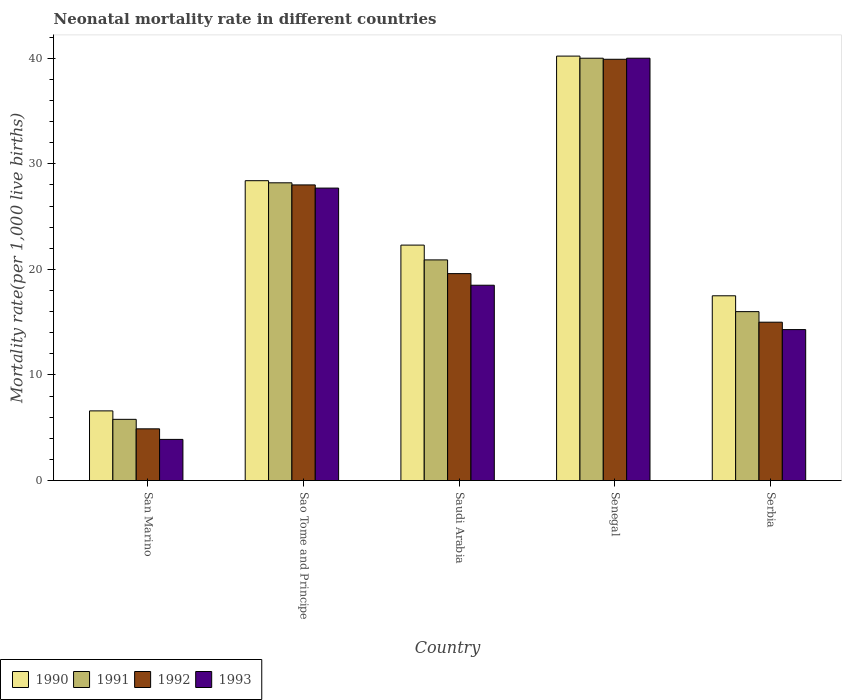How many bars are there on the 1st tick from the left?
Keep it short and to the point. 4. How many bars are there on the 4th tick from the right?
Offer a terse response. 4. What is the label of the 1st group of bars from the left?
Your answer should be compact. San Marino. In how many cases, is the number of bars for a given country not equal to the number of legend labels?
Provide a succinct answer. 0. What is the neonatal mortality rate in 1991 in Sao Tome and Principe?
Provide a succinct answer. 28.2. Across all countries, what is the maximum neonatal mortality rate in 1992?
Your answer should be compact. 39.9. Across all countries, what is the minimum neonatal mortality rate in 1991?
Offer a very short reply. 5.8. In which country was the neonatal mortality rate in 1992 maximum?
Provide a short and direct response. Senegal. In which country was the neonatal mortality rate in 1990 minimum?
Provide a succinct answer. San Marino. What is the total neonatal mortality rate in 1992 in the graph?
Your response must be concise. 107.4. What is the difference between the neonatal mortality rate in 1990 in Senegal and that in Serbia?
Offer a very short reply. 22.7. What is the difference between the neonatal mortality rate in 1992 in San Marino and the neonatal mortality rate in 1990 in Senegal?
Your answer should be compact. -35.3. What is the difference between the neonatal mortality rate of/in 1990 and neonatal mortality rate of/in 1993 in San Marino?
Offer a very short reply. 2.7. Is the neonatal mortality rate in 1992 in Sao Tome and Principe less than that in Saudi Arabia?
Your answer should be very brief. No. What is the difference between the highest and the lowest neonatal mortality rate in 1991?
Offer a terse response. 34.2. Is the sum of the neonatal mortality rate in 1992 in Saudi Arabia and Serbia greater than the maximum neonatal mortality rate in 1991 across all countries?
Keep it short and to the point. No. Is it the case that in every country, the sum of the neonatal mortality rate in 1991 and neonatal mortality rate in 1992 is greater than the neonatal mortality rate in 1990?
Keep it short and to the point. Yes. Are all the bars in the graph horizontal?
Keep it short and to the point. No. How many countries are there in the graph?
Your answer should be compact. 5. What is the difference between two consecutive major ticks on the Y-axis?
Your answer should be very brief. 10. Does the graph contain any zero values?
Keep it short and to the point. No. Where does the legend appear in the graph?
Give a very brief answer. Bottom left. How many legend labels are there?
Provide a short and direct response. 4. What is the title of the graph?
Your answer should be very brief. Neonatal mortality rate in different countries. What is the label or title of the Y-axis?
Your answer should be compact. Mortality rate(per 1,0 live births). What is the Mortality rate(per 1,000 live births) of 1992 in San Marino?
Offer a very short reply. 4.9. What is the Mortality rate(per 1,000 live births) of 1993 in San Marino?
Make the answer very short. 3.9. What is the Mortality rate(per 1,000 live births) of 1990 in Sao Tome and Principe?
Offer a very short reply. 28.4. What is the Mortality rate(per 1,000 live births) of 1991 in Sao Tome and Principe?
Your answer should be very brief. 28.2. What is the Mortality rate(per 1,000 live births) in 1992 in Sao Tome and Principe?
Your answer should be compact. 28. What is the Mortality rate(per 1,000 live births) in 1993 in Sao Tome and Principe?
Give a very brief answer. 27.7. What is the Mortality rate(per 1,000 live births) in 1990 in Saudi Arabia?
Provide a short and direct response. 22.3. What is the Mortality rate(per 1,000 live births) in 1991 in Saudi Arabia?
Your answer should be very brief. 20.9. What is the Mortality rate(per 1,000 live births) in 1992 in Saudi Arabia?
Provide a short and direct response. 19.6. What is the Mortality rate(per 1,000 live births) of 1993 in Saudi Arabia?
Provide a succinct answer. 18.5. What is the Mortality rate(per 1,000 live births) in 1990 in Senegal?
Provide a short and direct response. 40.2. What is the Mortality rate(per 1,000 live births) of 1992 in Senegal?
Offer a terse response. 39.9. What is the Mortality rate(per 1,000 live births) in 1993 in Senegal?
Keep it short and to the point. 40. What is the Mortality rate(per 1,000 live births) in 1991 in Serbia?
Keep it short and to the point. 16. What is the Mortality rate(per 1,000 live births) of 1993 in Serbia?
Provide a succinct answer. 14.3. Across all countries, what is the maximum Mortality rate(per 1,000 live births) in 1990?
Offer a terse response. 40.2. Across all countries, what is the maximum Mortality rate(per 1,000 live births) of 1991?
Give a very brief answer. 40. Across all countries, what is the maximum Mortality rate(per 1,000 live births) in 1992?
Make the answer very short. 39.9. Across all countries, what is the maximum Mortality rate(per 1,000 live births) of 1993?
Your answer should be compact. 40. Across all countries, what is the minimum Mortality rate(per 1,000 live births) of 1990?
Your answer should be compact. 6.6. What is the total Mortality rate(per 1,000 live births) of 1990 in the graph?
Provide a short and direct response. 115. What is the total Mortality rate(per 1,000 live births) of 1991 in the graph?
Offer a terse response. 110.9. What is the total Mortality rate(per 1,000 live births) of 1992 in the graph?
Provide a succinct answer. 107.4. What is the total Mortality rate(per 1,000 live births) of 1993 in the graph?
Keep it short and to the point. 104.4. What is the difference between the Mortality rate(per 1,000 live births) of 1990 in San Marino and that in Sao Tome and Principe?
Ensure brevity in your answer.  -21.8. What is the difference between the Mortality rate(per 1,000 live births) of 1991 in San Marino and that in Sao Tome and Principe?
Keep it short and to the point. -22.4. What is the difference between the Mortality rate(per 1,000 live births) in 1992 in San Marino and that in Sao Tome and Principe?
Keep it short and to the point. -23.1. What is the difference between the Mortality rate(per 1,000 live births) of 1993 in San Marino and that in Sao Tome and Principe?
Your answer should be compact. -23.8. What is the difference between the Mortality rate(per 1,000 live births) in 1990 in San Marino and that in Saudi Arabia?
Provide a short and direct response. -15.7. What is the difference between the Mortality rate(per 1,000 live births) in 1991 in San Marino and that in Saudi Arabia?
Provide a succinct answer. -15.1. What is the difference between the Mortality rate(per 1,000 live births) in 1992 in San Marino and that in Saudi Arabia?
Give a very brief answer. -14.7. What is the difference between the Mortality rate(per 1,000 live births) in 1993 in San Marino and that in Saudi Arabia?
Give a very brief answer. -14.6. What is the difference between the Mortality rate(per 1,000 live births) in 1990 in San Marino and that in Senegal?
Keep it short and to the point. -33.6. What is the difference between the Mortality rate(per 1,000 live births) of 1991 in San Marino and that in Senegal?
Your answer should be compact. -34.2. What is the difference between the Mortality rate(per 1,000 live births) of 1992 in San Marino and that in Senegal?
Keep it short and to the point. -35. What is the difference between the Mortality rate(per 1,000 live births) of 1993 in San Marino and that in Senegal?
Provide a succinct answer. -36.1. What is the difference between the Mortality rate(per 1,000 live births) of 1993 in San Marino and that in Serbia?
Provide a succinct answer. -10.4. What is the difference between the Mortality rate(per 1,000 live births) in 1990 in Sao Tome and Principe and that in Saudi Arabia?
Your response must be concise. 6.1. What is the difference between the Mortality rate(per 1,000 live births) of 1990 in Sao Tome and Principe and that in Senegal?
Ensure brevity in your answer.  -11.8. What is the difference between the Mortality rate(per 1,000 live births) of 1992 in Sao Tome and Principe and that in Senegal?
Ensure brevity in your answer.  -11.9. What is the difference between the Mortality rate(per 1,000 live births) in 1993 in Sao Tome and Principe and that in Senegal?
Provide a short and direct response. -12.3. What is the difference between the Mortality rate(per 1,000 live births) in 1990 in Sao Tome and Principe and that in Serbia?
Your answer should be compact. 10.9. What is the difference between the Mortality rate(per 1,000 live births) in 1992 in Sao Tome and Principe and that in Serbia?
Offer a very short reply. 13. What is the difference between the Mortality rate(per 1,000 live births) of 1993 in Sao Tome and Principe and that in Serbia?
Offer a terse response. 13.4. What is the difference between the Mortality rate(per 1,000 live births) in 1990 in Saudi Arabia and that in Senegal?
Your answer should be very brief. -17.9. What is the difference between the Mortality rate(per 1,000 live births) in 1991 in Saudi Arabia and that in Senegal?
Offer a terse response. -19.1. What is the difference between the Mortality rate(per 1,000 live births) in 1992 in Saudi Arabia and that in Senegal?
Your answer should be very brief. -20.3. What is the difference between the Mortality rate(per 1,000 live births) in 1993 in Saudi Arabia and that in Senegal?
Keep it short and to the point. -21.5. What is the difference between the Mortality rate(per 1,000 live births) of 1992 in Saudi Arabia and that in Serbia?
Provide a short and direct response. 4.6. What is the difference between the Mortality rate(per 1,000 live births) of 1993 in Saudi Arabia and that in Serbia?
Offer a very short reply. 4.2. What is the difference between the Mortality rate(per 1,000 live births) in 1990 in Senegal and that in Serbia?
Provide a short and direct response. 22.7. What is the difference between the Mortality rate(per 1,000 live births) of 1992 in Senegal and that in Serbia?
Make the answer very short. 24.9. What is the difference between the Mortality rate(per 1,000 live births) of 1993 in Senegal and that in Serbia?
Give a very brief answer. 25.7. What is the difference between the Mortality rate(per 1,000 live births) of 1990 in San Marino and the Mortality rate(per 1,000 live births) of 1991 in Sao Tome and Principe?
Ensure brevity in your answer.  -21.6. What is the difference between the Mortality rate(per 1,000 live births) in 1990 in San Marino and the Mortality rate(per 1,000 live births) in 1992 in Sao Tome and Principe?
Keep it short and to the point. -21.4. What is the difference between the Mortality rate(per 1,000 live births) of 1990 in San Marino and the Mortality rate(per 1,000 live births) of 1993 in Sao Tome and Principe?
Provide a short and direct response. -21.1. What is the difference between the Mortality rate(per 1,000 live births) in 1991 in San Marino and the Mortality rate(per 1,000 live births) in 1992 in Sao Tome and Principe?
Your answer should be very brief. -22.2. What is the difference between the Mortality rate(per 1,000 live births) in 1991 in San Marino and the Mortality rate(per 1,000 live births) in 1993 in Sao Tome and Principe?
Make the answer very short. -21.9. What is the difference between the Mortality rate(per 1,000 live births) of 1992 in San Marino and the Mortality rate(per 1,000 live births) of 1993 in Sao Tome and Principe?
Give a very brief answer. -22.8. What is the difference between the Mortality rate(per 1,000 live births) in 1990 in San Marino and the Mortality rate(per 1,000 live births) in 1991 in Saudi Arabia?
Give a very brief answer. -14.3. What is the difference between the Mortality rate(per 1,000 live births) in 1990 in San Marino and the Mortality rate(per 1,000 live births) in 1992 in Saudi Arabia?
Keep it short and to the point. -13. What is the difference between the Mortality rate(per 1,000 live births) in 1991 in San Marino and the Mortality rate(per 1,000 live births) in 1992 in Saudi Arabia?
Provide a succinct answer. -13.8. What is the difference between the Mortality rate(per 1,000 live births) in 1992 in San Marino and the Mortality rate(per 1,000 live births) in 1993 in Saudi Arabia?
Offer a very short reply. -13.6. What is the difference between the Mortality rate(per 1,000 live births) of 1990 in San Marino and the Mortality rate(per 1,000 live births) of 1991 in Senegal?
Provide a short and direct response. -33.4. What is the difference between the Mortality rate(per 1,000 live births) in 1990 in San Marino and the Mortality rate(per 1,000 live births) in 1992 in Senegal?
Give a very brief answer. -33.3. What is the difference between the Mortality rate(per 1,000 live births) in 1990 in San Marino and the Mortality rate(per 1,000 live births) in 1993 in Senegal?
Offer a terse response. -33.4. What is the difference between the Mortality rate(per 1,000 live births) in 1991 in San Marino and the Mortality rate(per 1,000 live births) in 1992 in Senegal?
Keep it short and to the point. -34.1. What is the difference between the Mortality rate(per 1,000 live births) in 1991 in San Marino and the Mortality rate(per 1,000 live births) in 1993 in Senegal?
Give a very brief answer. -34.2. What is the difference between the Mortality rate(per 1,000 live births) in 1992 in San Marino and the Mortality rate(per 1,000 live births) in 1993 in Senegal?
Your answer should be compact. -35.1. What is the difference between the Mortality rate(per 1,000 live births) in 1990 in San Marino and the Mortality rate(per 1,000 live births) in 1991 in Serbia?
Offer a terse response. -9.4. What is the difference between the Mortality rate(per 1,000 live births) in 1991 in San Marino and the Mortality rate(per 1,000 live births) in 1992 in Serbia?
Provide a succinct answer. -9.2. What is the difference between the Mortality rate(per 1,000 live births) in 1992 in San Marino and the Mortality rate(per 1,000 live births) in 1993 in Serbia?
Provide a short and direct response. -9.4. What is the difference between the Mortality rate(per 1,000 live births) of 1990 in Sao Tome and Principe and the Mortality rate(per 1,000 live births) of 1992 in Saudi Arabia?
Ensure brevity in your answer.  8.8. What is the difference between the Mortality rate(per 1,000 live births) in 1991 in Sao Tome and Principe and the Mortality rate(per 1,000 live births) in 1993 in Saudi Arabia?
Your response must be concise. 9.7. What is the difference between the Mortality rate(per 1,000 live births) of 1992 in Sao Tome and Principe and the Mortality rate(per 1,000 live births) of 1993 in Saudi Arabia?
Give a very brief answer. 9.5. What is the difference between the Mortality rate(per 1,000 live births) of 1990 in Sao Tome and Principe and the Mortality rate(per 1,000 live births) of 1991 in Senegal?
Give a very brief answer. -11.6. What is the difference between the Mortality rate(per 1,000 live births) of 1990 in Sao Tome and Principe and the Mortality rate(per 1,000 live births) of 1992 in Senegal?
Your answer should be compact. -11.5. What is the difference between the Mortality rate(per 1,000 live births) in 1990 in Sao Tome and Principe and the Mortality rate(per 1,000 live births) in 1993 in Senegal?
Your answer should be very brief. -11.6. What is the difference between the Mortality rate(per 1,000 live births) of 1991 in Sao Tome and Principe and the Mortality rate(per 1,000 live births) of 1993 in Senegal?
Your answer should be compact. -11.8. What is the difference between the Mortality rate(per 1,000 live births) in 1992 in Sao Tome and Principe and the Mortality rate(per 1,000 live births) in 1993 in Senegal?
Give a very brief answer. -12. What is the difference between the Mortality rate(per 1,000 live births) in 1990 in Sao Tome and Principe and the Mortality rate(per 1,000 live births) in 1993 in Serbia?
Your answer should be very brief. 14.1. What is the difference between the Mortality rate(per 1,000 live births) in 1992 in Sao Tome and Principe and the Mortality rate(per 1,000 live births) in 1993 in Serbia?
Offer a terse response. 13.7. What is the difference between the Mortality rate(per 1,000 live births) in 1990 in Saudi Arabia and the Mortality rate(per 1,000 live births) in 1991 in Senegal?
Your answer should be very brief. -17.7. What is the difference between the Mortality rate(per 1,000 live births) of 1990 in Saudi Arabia and the Mortality rate(per 1,000 live births) of 1992 in Senegal?
Your response must be concise. -17.6. What is the difference between the Mortality rate(per 1,000 live births) of 1990 in Saudi Arabia and the Mortality rate(per 1,000 live births) of 1993 in Senegal?
Ensure brevity in your answer.  -17.7. What is the difference between the Mortality rate(per 1,000 live births) of 1991 in Saudi Arabia and the Mortality rate(per 1,000 live births) of 1993 in Senegal?
Keep it short and to the point. -19.1. What is the difference between the Mortality rate(per 1,000 live births) of 1992 in Saudi Arabia and the Mortality rate(per 1,000 live births) of 1993 in Senegal?
Your answer should be compact. -20.4. What is the difference between the Mortality rate(per 1,000 live births) of 1990 in Saudi Arabia and the Mortality rate(per 1,000 live births) of 1992 in Serbia?
Keep it short and to the point. 7.3. What is the difference between the Mortality rate(per 1,000 live births) in 1991 in Saudi Arabia and the Mortality rate(per 1,000 live births) in 1993 in Serbia?
Give a very brief answer. 6.6. What is the difference between the Mortality rate(per 1,000 live births) in 1990 in Senegal and the Mortality rate(per 1,000 live births) in 1991 in Serbia?
Your response must be concise. 24.2. What is the difference between the Mortality rate(per 1,000 live births) of 1990 in Senegal and the Mortality rate(per 1,000 live births) of 1992 in Serbia?
Offer a very short reply. 25.2. What is the difference between the Mortality rate(per 1,000 live births) of 1990 in Senegal and the Mortality rate(per 1,000 live births) of 1993 in Serbia?
Your answer should be very brief. 25.9. What is the difference between the Mortality rate(per 1,000 live births) in 1991 in Senegal and the Mortality rate(per 1,000 live births) in 1992 in Serbia?
Your answer should be compact. 25. What is the difference between the Mortality rate(per 1,000 live births) of 1991 in Senegal and the Mortality rate(per 1,000 live births) of 1993 in Serbia?
Offer a terse response. 25.7. What is the difference between the Mortality rate(per 1,000 live births) of 1992 in Senegal and the Mortality rate(per 1,000 live births) of 1993 in Serbia?
Keep it short and to the point. 25.6. What is the average Mortality rate(per 1,000 live births) of 1990 per country?
Provide a short and direct response. 23. What is the average Mortality rate(per 1,000 live births) in 1991 per country?
Offer a terse response. 22.18. What is the average Mortality rate(per 1,000 live births) of 1992 per country?
Your answer should be very brief. 21.48. What is the average Mortality rate(per 1,000 live births) in 1993 per country?
Your answer should be very brief. 20.88. What is the difference between the Mortality rate(per 1,000 live births) in 1990 and Mortality rate(per 1,000 live births) in 1993 in San Marino?
Provide a succinct answer. 2.7. What is the difference between the Mortality rate(per 1,000 live births) in 1991 and Mortality rate(per 1,000 live births) in 1992 in San Marino?
Ensure brevity in your answer.  0.9. What is the difference between the Mortality rate(per 1,000 live births) of 1990 and Mortality rate(per 1,000 live births) of 1992 in Sao Tome and Principe?
Make the answer very short. 0.4. What is the difference between the Mortality rate(per 1,000 live births) of 1990 and Mortality rate(per 1,000 live births) of 1993 in Sao Tome and Principe?
Keep it short and to the point. 0.7. What is the difference between the Mortality rate(per 1,000 live births) in 1990 and Mortality rate(per 1,000 live births) in 1991 in Saudi Arabia?
Keep it short and to the point. 1.4. What is the difference between the Mortality rate(per 1,000 live births) of 1990 and Mortality rate(per 1,000 live births) of 1993 in Saudi Arabia?
Offer a terse response. 3.8. What is the difference between the Mortality rate(per 1,000 live births) of 1991 and Mortality rate(per 1,000 live births) of 1992 in Saudi Arabia?
Keep it short and to the point. 1.3. What is the difference between the Mortality rate(per 1,000 live births) of 1991 and Mortality rate(per 1,000 live births) of 1993 in Saudi Arabia?
Make the answer very short. 2.4. What is the difference between the Mortality rate(per 1,000 live births) of 1990 and Mortality rate(per 1,000 live births) of 1991 in Senegal?
Keep it short and to the point. 0.2. What is the difference between the Mortality rate(per 1,000 live births) of 1991 and Mortality rate(per 1,000 live births) of 1992 in Senegal?
Give a very brief answer. 0.1. What is the difference between the Mortality rate(per 1,000 live births) of 1991 and Mortality rate(per 1,000 live births) of 1993 in Senegal?
Offer a very short reply. 0. What is the difference between the Mortality rate(per 1,000 live births) in 1990 and Mortality rate(per 1,000 live births) in 1991 in Serbia?
Your answer should be compact. 1.5. What is the difference between the Mortality rate(per 1,000 live births) of 1990 and Mortality rate(per 1,000 live births) of 1992 in Serbia?
Offer a very short reply. 2.5. What is the difference between the Mortality rate(per 1,000 live births) of 1991 and Mortality rate(per 1,000 live births) of 1992 in Serbia?
Provide a short and direct response. 1. What is the ratio of the Mortality rate(per 1,000 live births) in 1990 in San Marino to that in Sao Tome and Principe?
Provide a short and direct response. 0.23. What is the ratio of the Mortality rate(per 1,000 live births) in 1991 in San Marino to that in Sao Tome and Principe?
Your answer should be compact. 0.21. What is the ratio of the Mortality rate(per 1,000 live births) in 1992 in San Marino to that in Sao Tome and Principe?
Your response must be concise. 0.17. What is the ratio of the Mortality rate(per 1,000 live births) in 1993 in San Marino to that in Sao Tome and Principe?
Make the answer very short. 0.14. What is the ratio of the Mortality rate(per 1,000 live births) in 1990 in San Marino to that in Saudi Arabia?
Make the answer very short. 0.3. What is the ratio of the Mortality rate(per 1,000 live births) of 1991 in San Marino to that in Saudi Arabia?
Make the answer very short. 0.28. What is the ratio of the Mortality rate(per 1,000 live births) of 1993 in San Marino to that in Saudi Arabia?
Keep it short and to the point. 0.21. What is the ratio of the Mortality rate(per 1,000 live births) of 1990 in San Marino to that in Senegal?
Provide a short and direct response. 0.16. What is the ratio of the Mortality rate(per 1,000 live births) of 1991 in San Marino to that in Senegal?
Keep it short and to the point. 0.14. What is the ratio of the Mortality rate(per 1,000 live births) of 1992 in San Marino to that in Senegal?
Offer a very short reply. 0.12. What is the ratio of the Mortality rate(per 1,000 live births) of 1993 in San Marino to that in Senegal?
Your response must be concise. 0.1. What is the ratio of the Mortality rate(per 1,000 live births) in 1990 in San Marino to that in Serbia?
Ensure brevity in your answer.  0.38. What is the ratio of the Mortality rate(per 1,000 live births) in 1991 in San Marino to that in Serbia?
Your answer should be very brief. 0.36. What is the ratio of the Mortality rate(per 1,000 live births) in 1992 in San Marino to that in Serbia?
Provide a short and direct response. 0.33. What is the ratio of the Mortality rate(per 1,000 live births) in 1993 in San Marino to that in Serbia?
Give a very brief answer. 0.27. What is the ratio of the Mortality rate(per 1,000 live births) of 1990 in Sao Tome and Principe to that in Saudi Arabia?
Provide a short and direct response. 1.27. What is the ratio of the Mortality rate(per 1,000 live births) of 1991 in Sao Tome and Principe to that in Saudi Arabia?
Ensure brevity in your answer.  1.35. What is the ratio of the Mortality rate(per 1,000 live births) of 1992 in Sao Tome and Principe to that in Saudi Arabia?
Make the answer very short. 1.43. What is the ratio of the Mortality rate(per 1,000 live births) of 1993 in Sao Tome and Principe to that in Saudi Arabia?
Provide a succinct answer. 1.5. What is the ratio of the Mortality rate(per 1,000 live births) in 1990 in Sao Tome and Principe to that in Senegal?
Ensure brevity in your answer.  0.71. What is the ratio of the Mortality rate(per 1,000 live births) of 1991 in Sao Tome and Principe to that in Senegal?
Keep it short and to the point. 0.7. What is the ratio of the Mortality rate(per 1,000 live births) in 1992 in Sao Tome and Principe to that in Senegal?
Offer a very short reply. 0.7. What is the ratio of the Mortality rate(per 1,000 live births) of 1993 in Sao Tome and Principe to that in Senegal?
Your answer should be compact. 0.69. What is the ratio of the Mortality rate(per 1,000 live births) of 1990 in Sao Tome and Principe to that in Serbia?
Ensure brevity in your answer.  1.62. What is the ratio of the Mortality rate(per 1,000 live births) of 1991 in Sao Tome and Principe to that in Serbia?
Your response must be concise. 1.76. What is the ratio of the Mortality rate(per 1,000 live births) of 1992 in Sao Tome and Principe to that in Serbia?
Provide a succinct answer. 1.87. What is the ratio of the Mortality rate(per 1,000 live births) of 1993 in Sao Tome and Principe to that in Serbia?
Your response must be concise. 1.94. What is the ratio of the Mortality rate(per 1,000 live births) of 1990 in Saudi Arabia to that in Senegal?
Offer a very short reply. 0.55. What is the ratio of the Mortality rate(per 1,000 live births) of 1991 in Saudi Arabia to that in Senegal?
Your answer should be compact. 0.52. What is the ratio of the Mortality rate(per 1,000 live births) in 1992 in Saudi Arabia to that in Senegal?
Your answer should be very brief. 0.49. What is the ratio of the Mortality rate(per 1,000 live births) of 1993 in Saudi Arabia to that in Senegal?
Provide a succinct answer. 0.46. What is the ratio of the Mortality rate(per 1,000 live births) in 1990 in Saudi Arabia to that in Serbia?
Your response must be concise. 1.27. What is the ratio of the Mortality rate(per 1,000 live births) in 1991 in Saudi Arabia to that in Serbia?
Your response must be concise. 1.31. What is the ratio of the Mortality rate(per 1,000 live births) of 1992 in Saudi Arabia to that in Serbia?
Give a very brief answer. 1.31. What is the ratio of the Mortality rate(per 1,000 live births) of 1993 in Saudi Arabia to that in Serbia?
Keep it short and to the point. 1.29. What is the ratio of the Mortality rate(per 1,000 live births) in 1990 in Senegal to that in Serbia?
Provide a succinct answer. 2.3. What is the ratio of the Mortality rate(per 1,000 live births) in 1991 in Senegal to that in Serbia?
Ensure brevity in your answer.  2.5. What is the ratio of the Mortality rate(per 1,000 live births) in 1992 in Senegal to that in Serbia?
Your response must be concise. 2.66. What is the ratio of the Mortality rate(per 1,000 live births) in 1993 in Senegal to that in Serbia?
Give a very brief answer. 2.8. What is the difference between the highest and the second highest Mortality rate(per 1,000 live births) of 1990?
Offer a very short reply. 11.8. What is the difference between the highest and the second highest Mortality rate(per 1,000 live births) in 1991?
Offer a terse response. 11.8. What is the difference between the highest and the second highest Mortality rate(per 1,000 live births) in 1993?
Your answer should be very brief. 12.3. What is the difference between the highest and the lowest Mortality rate(per 1,000 live births) in 1990?
Your answer should be very brief. 33.6. What is the difference between the highest and the lowest Mortality rate(per 1,000 live births) in 1991?
Provide a succinct answer. 34.2. What is the difference between the highest and the lowest Mortality rate(per 1,000 live births) in 1992?
Ensure brevity in your answer.  35. What is the difference between the highest and the lowest Mortality rate(per 1,000 live births) in 1993?
Give a very brief answer. 36.1. 